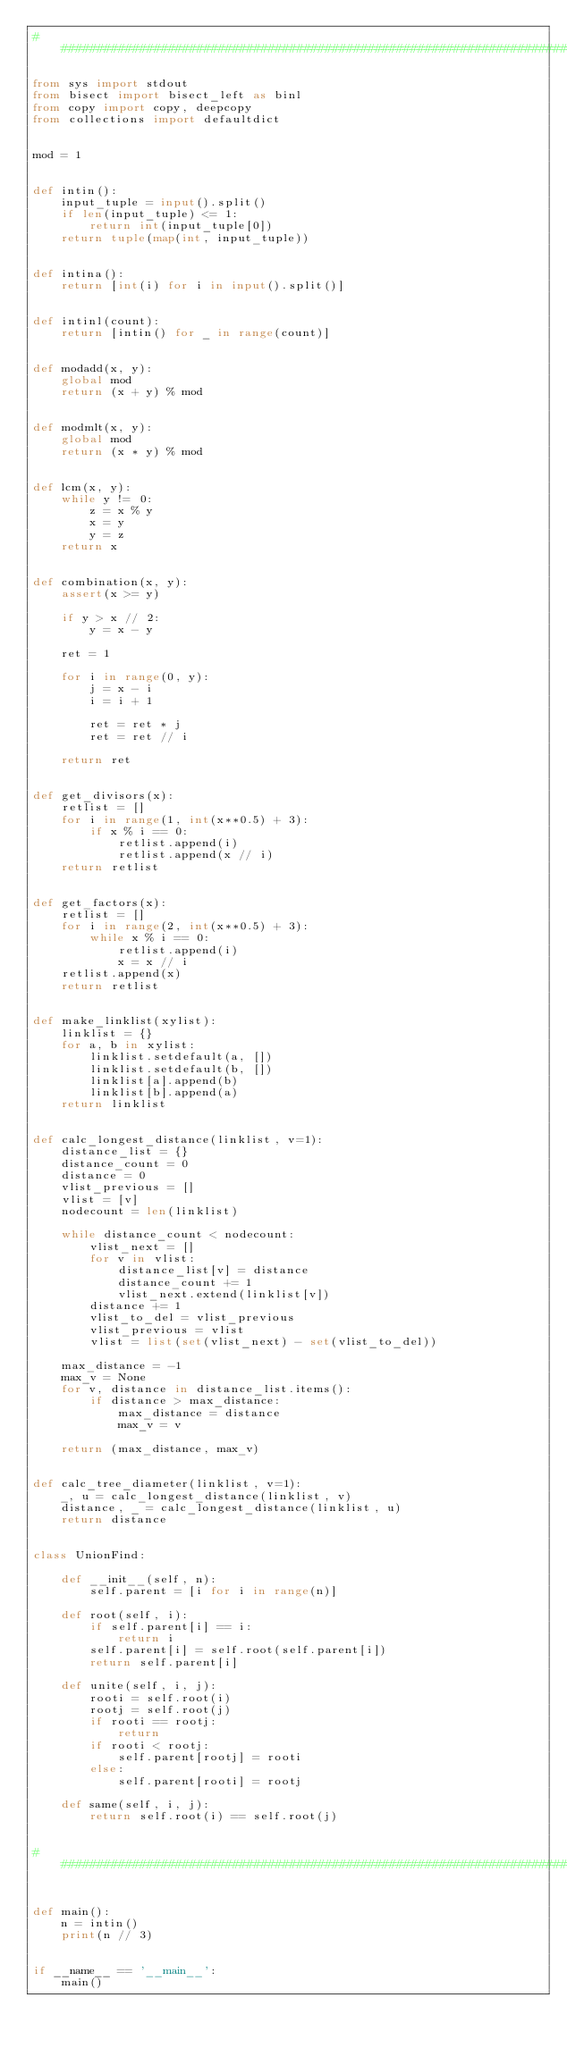Convert code to text. <code><loc_0><loc_0><loc_500><loc_500><_Python_>###############################################################################

from sys import stdout
from bisect import bisect_left as binl
from copy import copy, deepcopy
from collections import defaultdict


mod = 1


def intin():
    input_tuple = input().split()
    if len(input_tuple) <= 1:
        return int(input_tuple[0])
    return tuple(map(int, input_tuple))


def intina():
    return [int(i) for i in input().split()]


def intinl(count):
    return [intin() for _ in range(count)]


def modadd(x, y):
    global mod
    return (x + y) % mod


def modmlt(x, y):
    global mod
    return (x * y) % mod


def lcm(x, y):
    while y != 0:
        z = x % y
        x = y
        y = z
    return x


def combination(x, y):
    assert(x >= y)

    if y > x // 2:
        y = x - y

    ret = 1

    for i in range(0, y):
        j = x - i
        i = i + 1

        ret = ret * j
        ret = ret // i

    return ret


def get_divisors(x):
    retlist = []
    for i in range(1, int(x**0.5) + 3):
        if x % i == 0:
            retlist.append(i)
            retlist.append(x // i)
    return retlist


def get_factors(x):
    retlist = []
    for i in range(2, int(x**0.5) + 3):
        while x % i == 0:
            retlist.append(i)
            x = x // i
    retlist.append(x)
    return retlist


def make_linklist(xylist):
    linklist = {}
    for a, b in xylist:
        linklist.setdefault(a, [])
        linklist.setdefault(b, [])
        linklist[a].append(b)
        linklist[b].append(a)
    return linklist


def calc_longest_distance(linklist, v=1):
    distance_list = {}
    distance_count = 0
    distance = 0
    vlist_previous = []
    vlist = [v]
    nodecount = len(linklist)

    while distance_count < nodecount:
        vlist_next = []
        for v in vlist:
            distance_list[v] = distance
            distance_count += 1
            vlist_next.extend(linklist[v])
        distance += 1
        vlist_to_del = vlist_previous
        vlist_previous = vlist
        vlist = list(set(vlist_next) - set(vlist_to_del))

    max_distance = -1
    max_v = None
    for v, distance in distance_list.items():
        if distance > max_distance:
            max_distance = distance
            max_v = v

    return (max_distance, max_v)


def calc_tree_diameter(linklist, v=1):
    _, u = calc_longest_distance(linklist, v)
    distance, _ = calc_longest_distance(linklist, u)
    return distance


class UnionFind:

    def __init__(self, n):
        self.parent = [i for i in range(n)]

    def root(self, i):
        if self.parent[i] == i:
            return i
        self.parent[i] = self.root(self.parent[i])
        return self.parent[i]

    def unite(self, i, j):
        rooti = self.root(i)
        rootj = self.root(j)
        if rooti == rootj:
            return
        if rooti < rootj:
            self.parent[rootj] = rooti
        else:
            self.parent[rooti] = rootj

    def same(self, i, j):
        return self.root(i) == self.root(j)


###############################################################################


def main():
    n = intin()
    print(n // 3)


if __name__ == '__main__':
    main()
</code> 